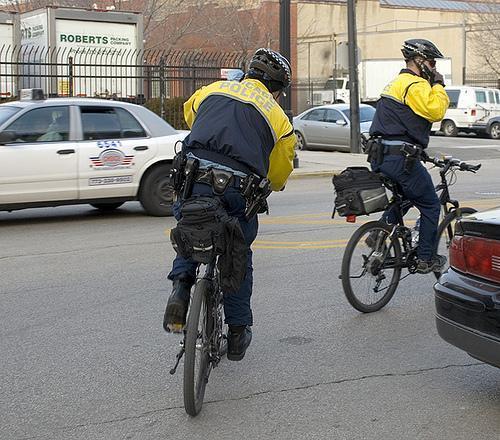How many bikes are there?
Give a very brief answer. 2. How many bicycles are visible?
Give a very brief answer. 2. How many backpacks are visible?
Give a very brief answer. 2. How many cars can you see?
Give a very brief answer. 4. How many people are in the picture?
Give a very brief answer. 2. How many trucks are visible?
Give a very brief answer. 3. How many elephants are to the right of another elephant?
Give a very brief answer. 0. 